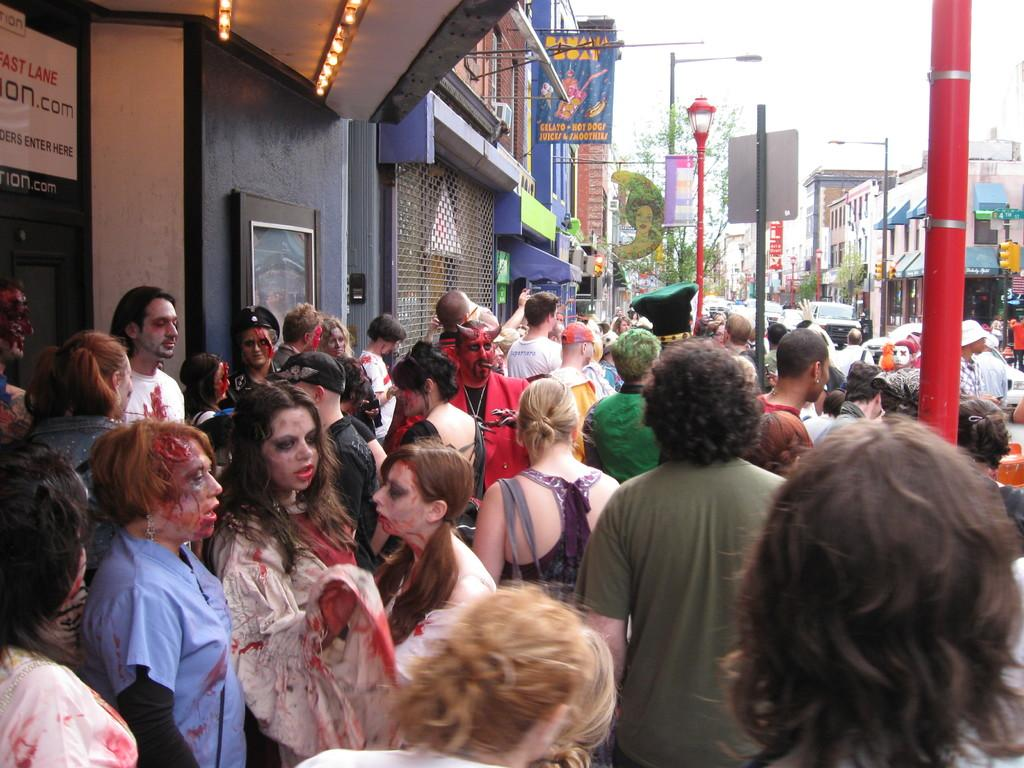What is the theme of the party depicted in the image? The image depicts a Halloween party. What is the main object located in front of the building? There is a large crown standing in front of the building. Where is the crown positioned in relation to the footpath? The crown is beside the footpath. What can be seen in the background of the image? There are stores and trees visible in the background, as well as the sky. What type of sock is hanging from the tree in the image? There is no sock present in the image; it depicts a Halloween party with a large crown standing in front of a building. 